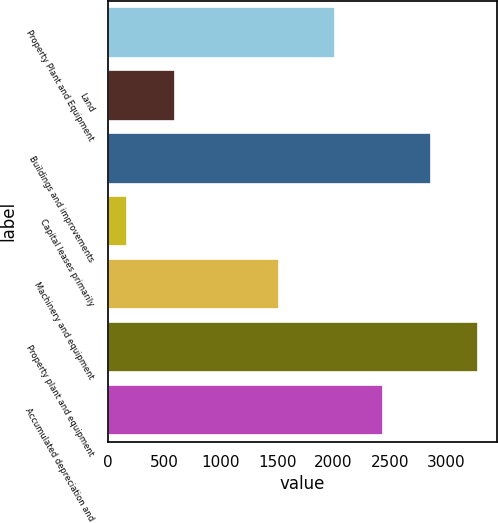Convert chart. <chart><loc_0><loc_0><loc_500><loc_500><bar_chart><fcel>Property Plant and Equipment<fcel>Land<fcel>Buildings and improvements<fcel>Capital leases primarily<fcel>Machinery and equipment<fcel>Property plant and equipment<fcel>Accumulated depreciation and<nl><fcel>2015<fcel>590.7<fcel>2860.4<fcel>168<fcel>1515<fcel>3283.1<fcel>2437.7<nl></chart> 